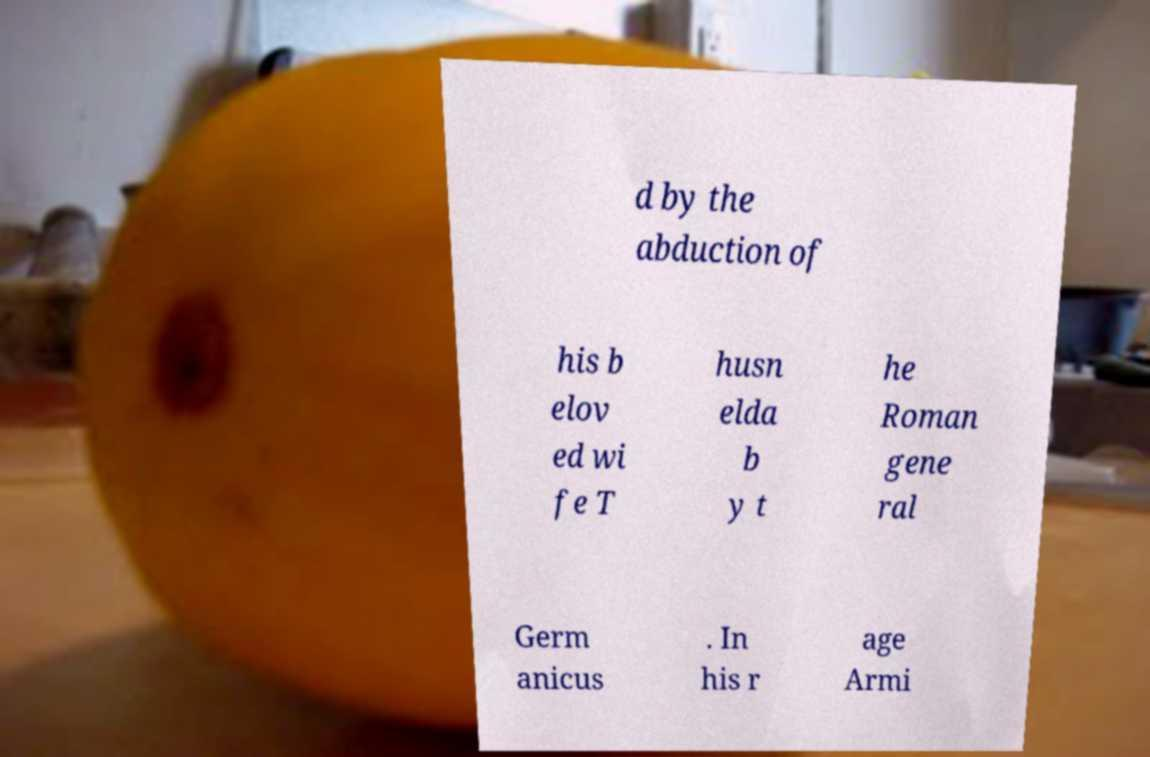Can you read and provide the text displayed in the image?This photo seems to have some interesting text. Can you extract and type it out for me? d by the abduction of his b elov ed wi fe T husn elda b y t he Roman gene ral Germ anicus . In his r age Armi 